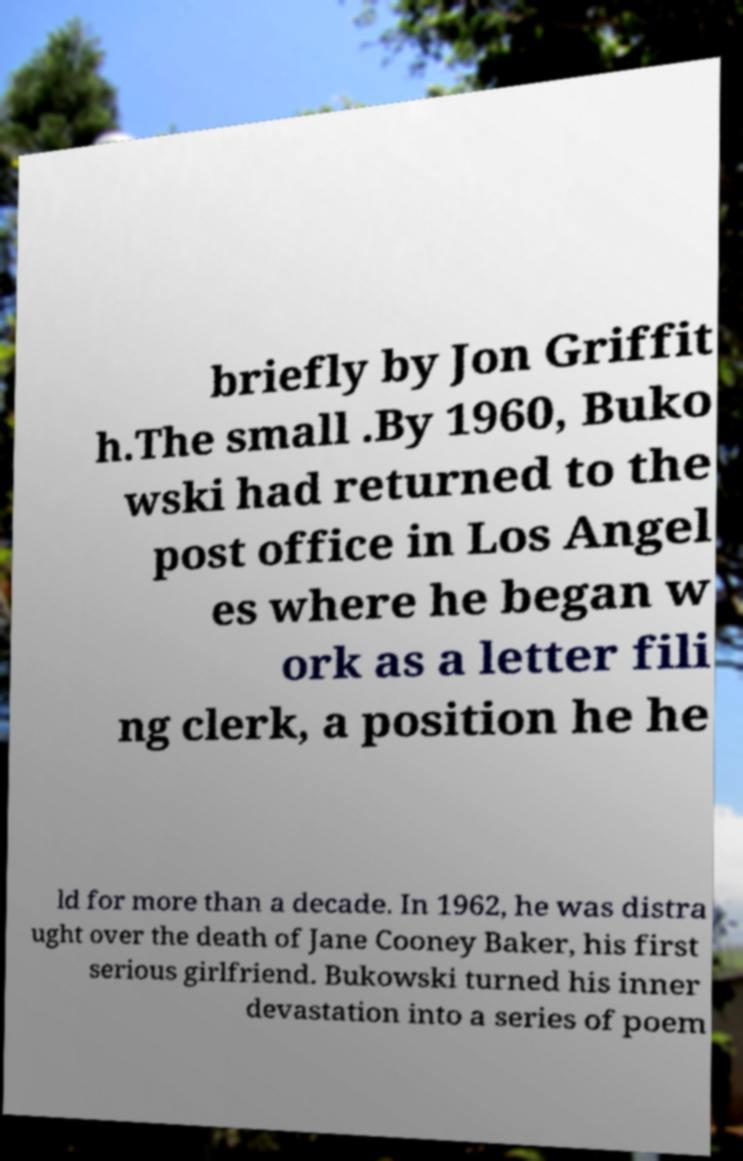For documentation purposes, I need the text within this image transcribed. Could you provide that? briefly by Jon Griffit h.The small .By 1960, Buko wski had returned to the post office in Los Angel es where he began w ork as a letter fili ng clerk, a position he he ld for more than a decade. In 1962, he was distra ught over the death of Jane Cooney Baker, his first serious girlfriend. Bukowski turned his inner devastation into a series of poem 